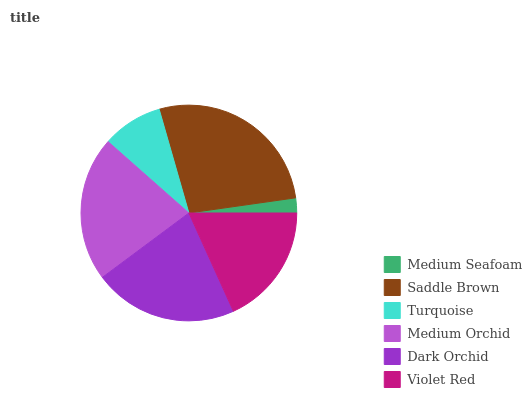Is Medium Seafoam the minimum?
Answer yes or no. Yes. Is Saddle Brown the maximum?
Answer yes or no. Yes. Is Turquoise the minimum?
Answer yes or no. No. Is Turquoise the maximum?
Answer yes or no. No. Is Saddle Brown greater than Turquoise?
Answer yes or no. Yes. Is Turquoise less than Saddle Brown?
Answer yes or no. Yes. Is Turquoise greater than Saddle Brown?
Answer yes or no. No. Is Saddle Brown less than Turquoise?
Answer yes or no. No. Is Dark Orchid the high median?
Answer yes or no. Yes. Is Violet Red the low median?
Answer yes or no. Yes. Is Turquoise the high median?
Answer yes or no. No. Is Dark Orchid the low median?
Answer yes or no. No. 